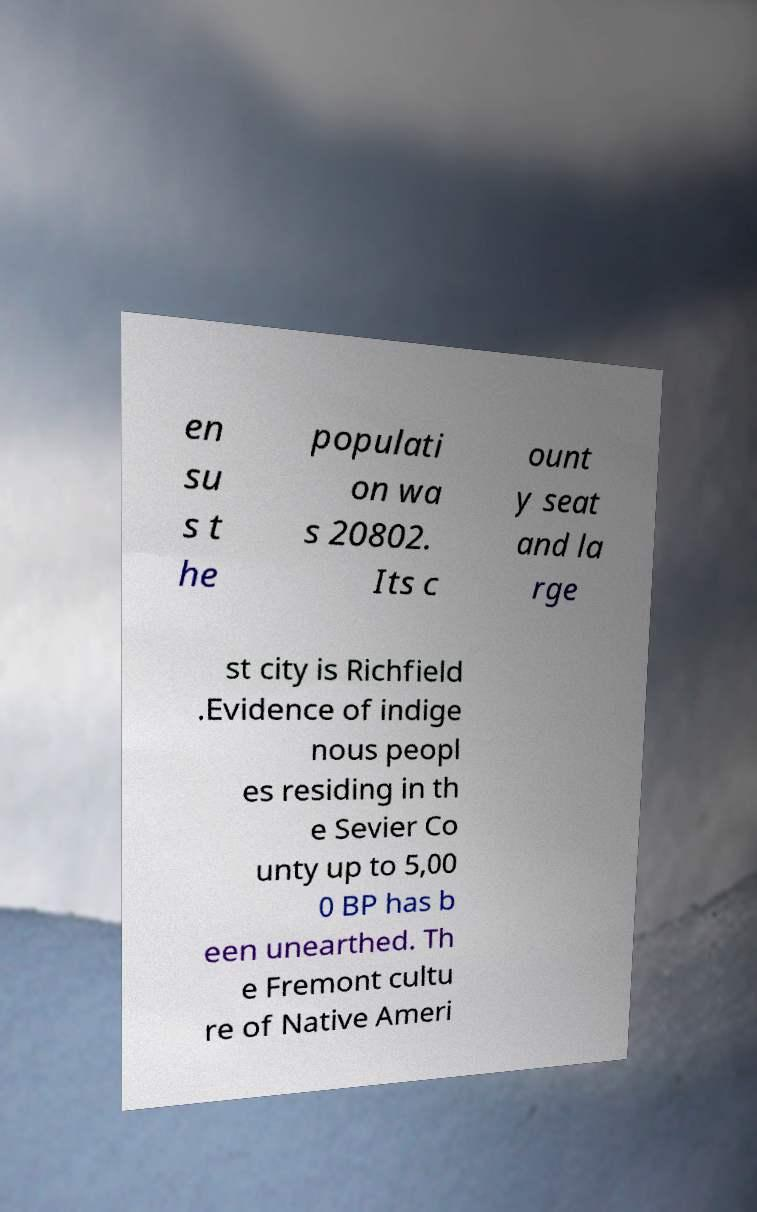What messages or text are displayed in this image? I need them in a readable, typed format. en su s t he populati on wa s 20802. Its c ount y seat and la rge st city is Richfield .Evidence of indige nous peopl es residing in th e Sevier Co unty up to 5,00 0 BP has b een unearthed. Th e Fremont cultu re of Native Ameri 